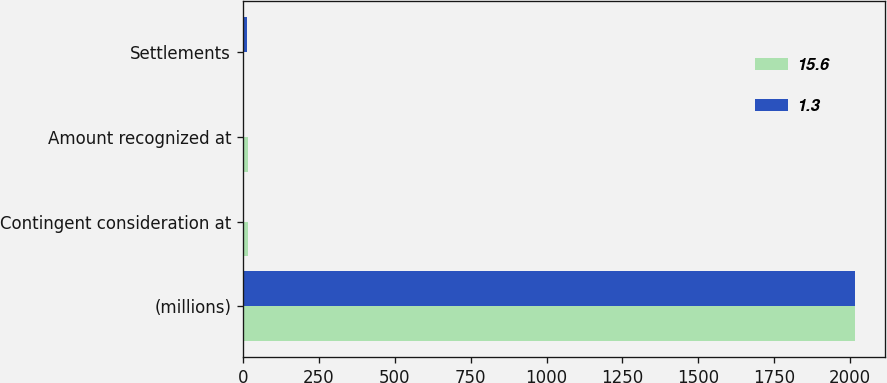Convert chart. <chart><loc_0><loc_0><loc_500><loc_500><stacked_bar_chart><ecel><fcel>(millions)<fcel>Contingent consideration at<fcel>Amount recognized at<fcel>Settlements<nl><fcel>15.6<fcel>2015<fcel>15.6<fcel>16<fcel>1<nl><fcel>1.3<fcel>2014<fcel>1.3<fcel>0.4<fcel>14.3<nl></chart> 